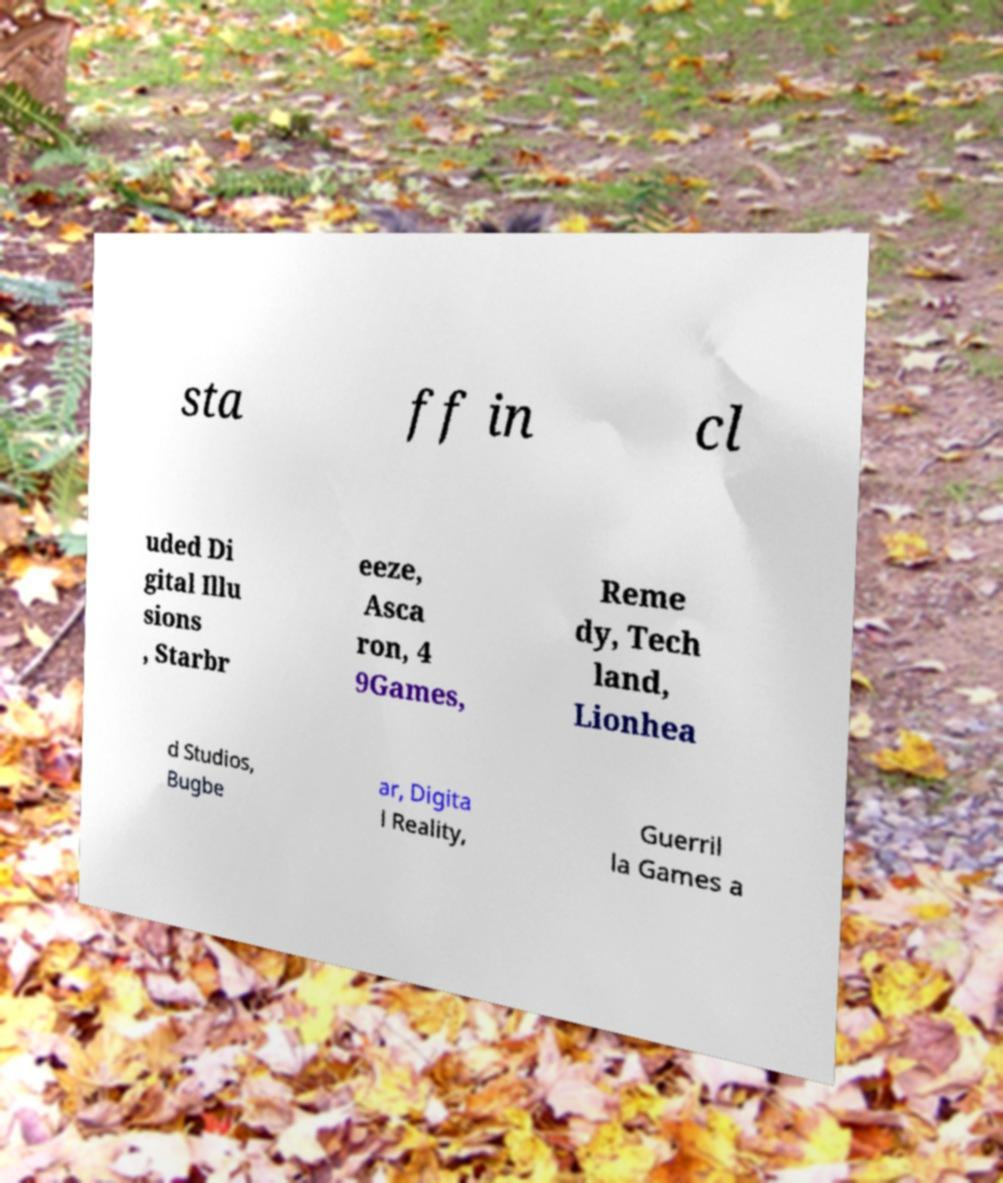Can you read and provide the text displayed in the image?This photo seems to have some interesting text. Can you extract and type it out for me? sta ff in cl uded Di gital Illu sions , Starbr eeze, Asca ron, 4 9Games, Reme dy, Tech land, Lionhea d Studios, Bugbe ar, Digita l Reality, Guerril la Games a 